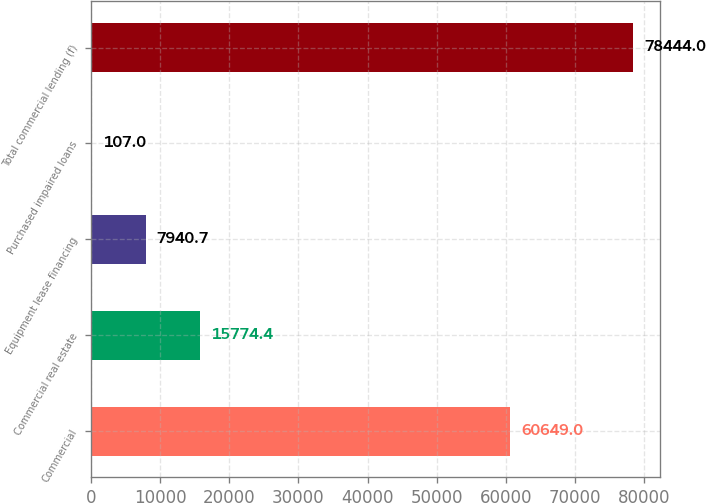Convert chart to OTSL. <chart><loc_0><loc_0><loc_500><loc_500><bar_chart><fcel>Commercial<fcel>Commercial real estate<fcel>Equipment lease financing<fcel>Purchased impaired loans<fcel>Total commercial lending (f)<nl><fcel>60649<fcel>15774.4<fcel>7940.7<fcel>107<fcel>78444<nl></chart> 